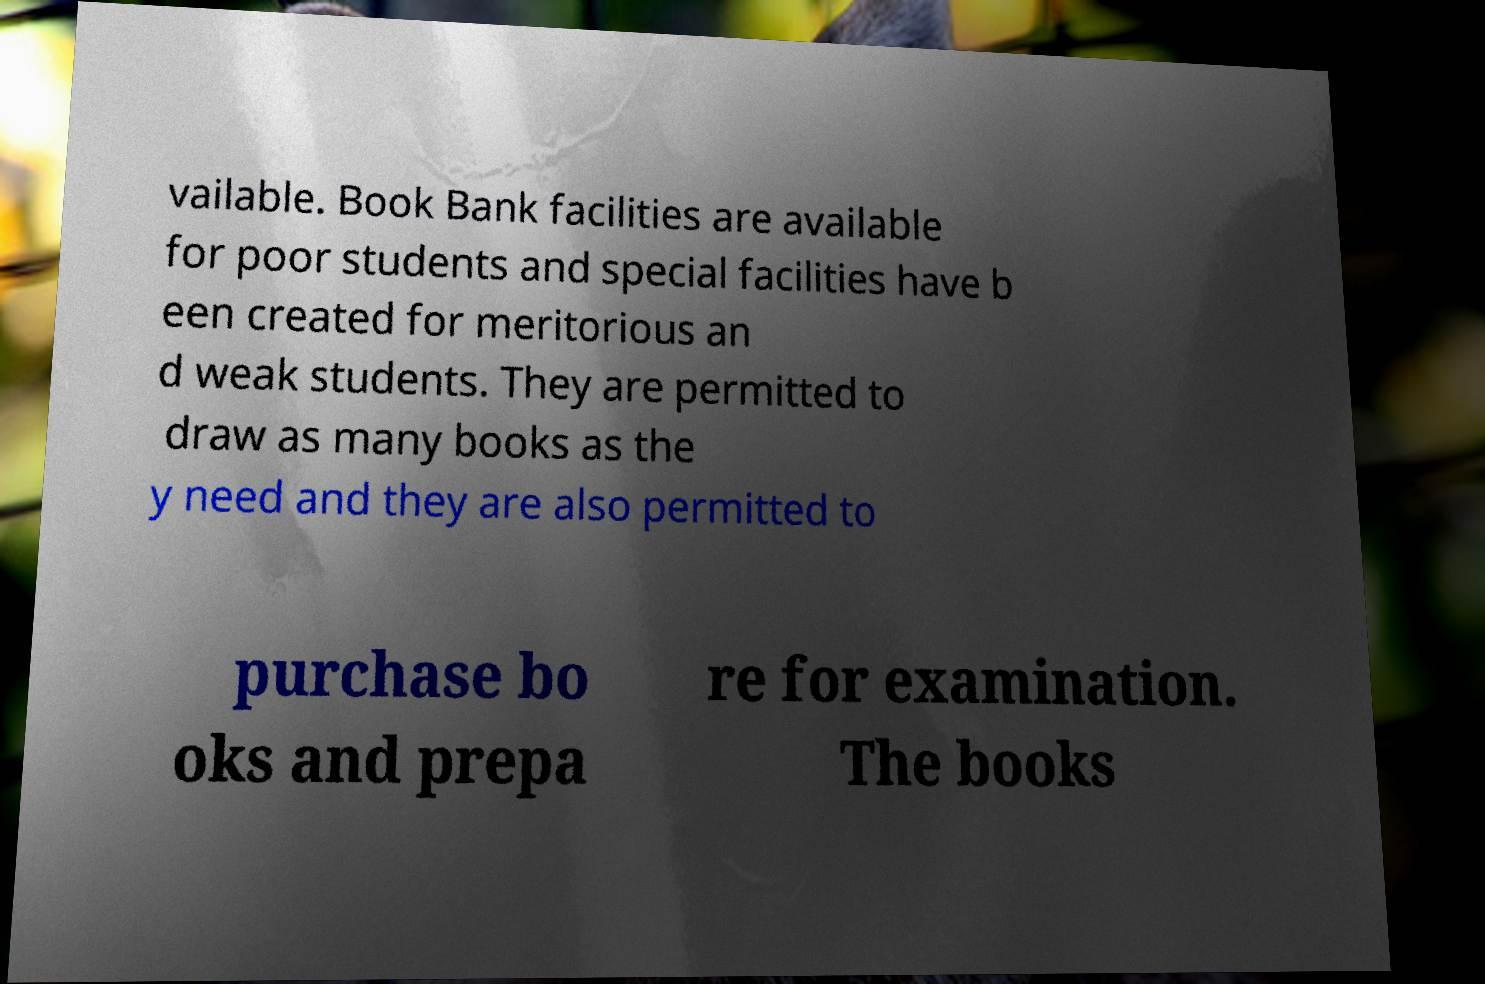Could you assist in decoding the text presented in this image and type it out clearly? vailable. Book Bank facilities are available for poor students and special facilities have b een created for meritorious an d weak students. They are permitted to draw as many books as the y need and they are also permitted to purchase bo oks and prepa re for examination. The books 